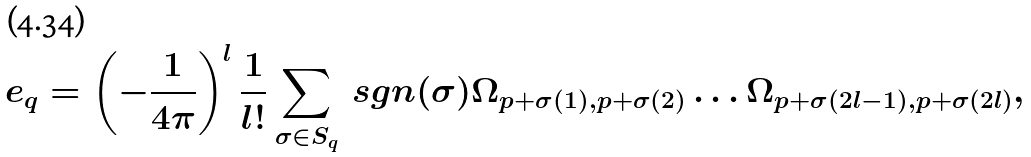<formula> <loc_0><loc_0><loc_500><loc_500>e _ { q } = \left ( - \frac { 1 } { 4 \pi } \right ) ^ { l } \frac { 1 } { l ! } \sum _ { \sigma \in S _ { q } } \ s g n ( \sigma ) \Omega _ { p + \sigma ( 1 ) , p + \sigma ( 2 ) } \dots \Omega _ { p + \sigma ( 2 l - 1 ) , p + \sigma ( 2 l ) } ,</formula> 